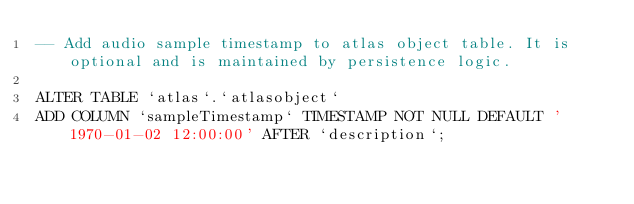<code> <loc_0><loc_0><loc_500><loc_500><_SQL_>-- Add audio sample timestamp to atlas object table. It is optional and is maintained by persistence logic.

ALTER TABLE `atlas`.`atlasobject` 
ADD COLUMN `sampleTimestamp` TIMESTAMP NOT NULL DEFAULT '1970-01-02 12:00:00' AFTER `description`;
</code> 